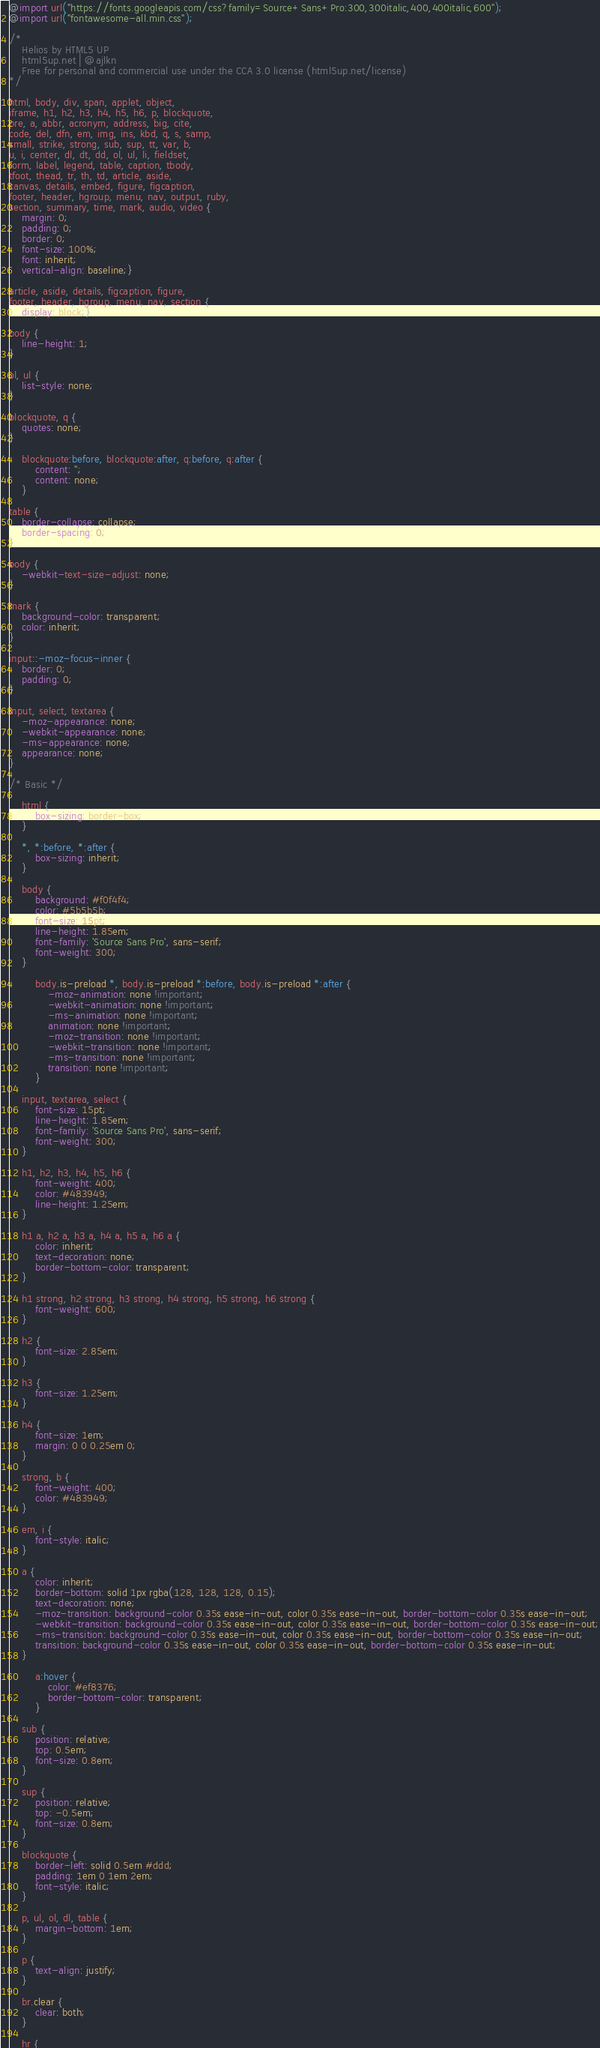Convert code to text. <code><loc_0><loc_0><loc_500><loc_500><_CSS_>@import url("https://fonts.googleapis.com/css?family=Source+Sans+Pro:300,300italic,400,400italic,600");
@import url("fontawesome-all.min.css");

/*
	Helios by HTML5 UP
	html5up.net | @ajlkn
	Free for personal and commercial use under the CCA 3.0 license (html5up.net/license)
*/

html, body, div, span, applet, object,
iframe, h1, h2, h3, h4, h5, h6, p, blockquote,
pre, a, abbr, acronym, address, big, cite,
code, del, dfn, em, img, ins, kbd, q, s, samp,
small, strike, strong, sub, sup, tt, var, b,
u, i, center, dl, dt, dd, ol, ul, li, fieldset,
form, label, legend, table, caption, tbody,
tfoot, thead, tr, th, td, article, aside,
canvas, details, embed, figure, figcaption,
footer, header, hgroup, menu, nav, output, ruby,
section, summary, time, mark, audio, video {
	margin: 0;
	padding: 0;
	border: 0;
	font-size: 100%;
	font: inherit;
	vertical-align: baseline;}

article, aside, details, figcaption, figure,
footer, header, hgroup, menu, nav, section {
	display: block;}

body {
	line-height: 1;
}

ol, ul {
	list-style: none;
}

blockquote, q {
	quotes: none;
}

	blockquote:before, blockquote:after, q:before, q:after {
		content: '';
		content: none;
	}

table {
	border-collapse: collapse;
	border-spacing: 0;
}

body {
	-webkit-text-size-adjust: none;
}

mark {
	background-color: transparent;
	color: inherit;
}

input::-moz-focus-inner {
	border: 0;
	padding: 0;
}

input, select, textarea {
	-moz-appearance: none;
	-webkit-appearance: none;
	-ms-appearance: none;
	appearance: none;
}

/* Basic */

	html {
		box-sizing: border-box;
	}

	*, *:before, *:after {
		box-sizing: inherit;
	}

	body {
		background: #f0f4f4;
		color: #5b5b5b;
		font-size: 15pt;
		line-height: 1.85em;
		font-family: 'Source Sans Pro', sans-serif;
		font-weight: 300;
	}

		body.is-preload *, body.is-preload *:before, body.is-preload *:after {
			-moz-animation: none !important;
			-webkit-animation: none !important;
			-ms-animation: none !important;
			animation: none !important;
			-moz-transition: none !important;
			-webkit-transition: none !important;
			-ms-transition: none !important;
			transition: none !important;
		}

	input, textarea, select {
		font-size: 15pt;
		line-height: 1.85em;
		font-family: 'Source Sans Pro', sans-serif;
		font-weight: 300;
	}

	h1, h2, h3, h4, h5, h6 {
		font-weight: 400;
		color: #483949;
		line-height: 1.25em;
	}

	h1 a, h2 a, h3 a, h4 a, h5 a, h6 a {
		color: inherit;
		text-decoration: none;
		border-bottom-color: transparent;
	}

	h1 strong, h2 strong, h3 strong, h4 strong, h5 strong, h6 strong {
		font-weight: 600;
	}

	h2 {
		font-size: 2.85em;
	}

	h3 {
		font-size: 1.25em;
	}

	h4 {
		font-size: 1em;
		margin: 0 0 0.25em 0;
	}

	strong, b {
		font-weight: 400;
		color: #483949;
	}

	em, i {
		font-style: italic;
	}

	a {
		color: inherit;
		border-bottom: solid 1px rgba(128, 128, 128, 0.15);
		text-decoration: none;
		-moz-transition: background-color 0.35s ease-in-out, color 0.35s ease-in-out, border-bottom-color 0.35s ease-in-out;
		-webkit-transition: background-color 0.35s ease-in-out, color 0.35s ease-in-out, border-bottom-color 0.35s ease-in-out;
		-ms-transition: background-color 0.35s ease-in-out, color 0.35s ease-in-out, border-bottom-color 0.35s ease-in-out;
		transition: background-color 0.35s ease-in-out, color 0.35s ease-in-out, border-bottom-color 0.35s ease-in-out;
	}

		a:hover {
			color: #ef8376;
			border-bottom-color: transparent;
		}

	sub {
		position: relative;
		top: 0.5em;
		font-size: 0.8em;
	}

	sup {
		position: relative;
		top: -0.5em;
		font-size: 0.8em;
	}

	blockquote {
		border-left: solid 0.5em #ddd;
		padding: 1em 0 1em 2em;
		font-style: italic;
	}

	p, ul, ol, dl, table {
		margin-bottom: 1em;
	}

	p {
		text-align: justify;
	}

	br.clear {
		clear: both;
	}

	hr {</code> 